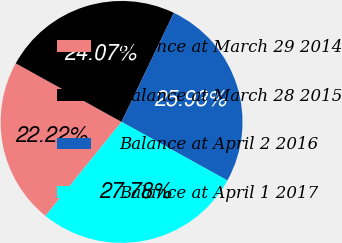<chart> <loc_0><loc_0><loc_500><loc_500><pie_chart><fcel>Balance at March 29 2014<fcel>Balance at March 28 2015<fcel>Balance at April 2 2016<fcel>Balance at April 1 2017<nl><fcel>22.22%<fcel>24.07%<fcel>25.93%<fcel>27.78%<nl></chart> 